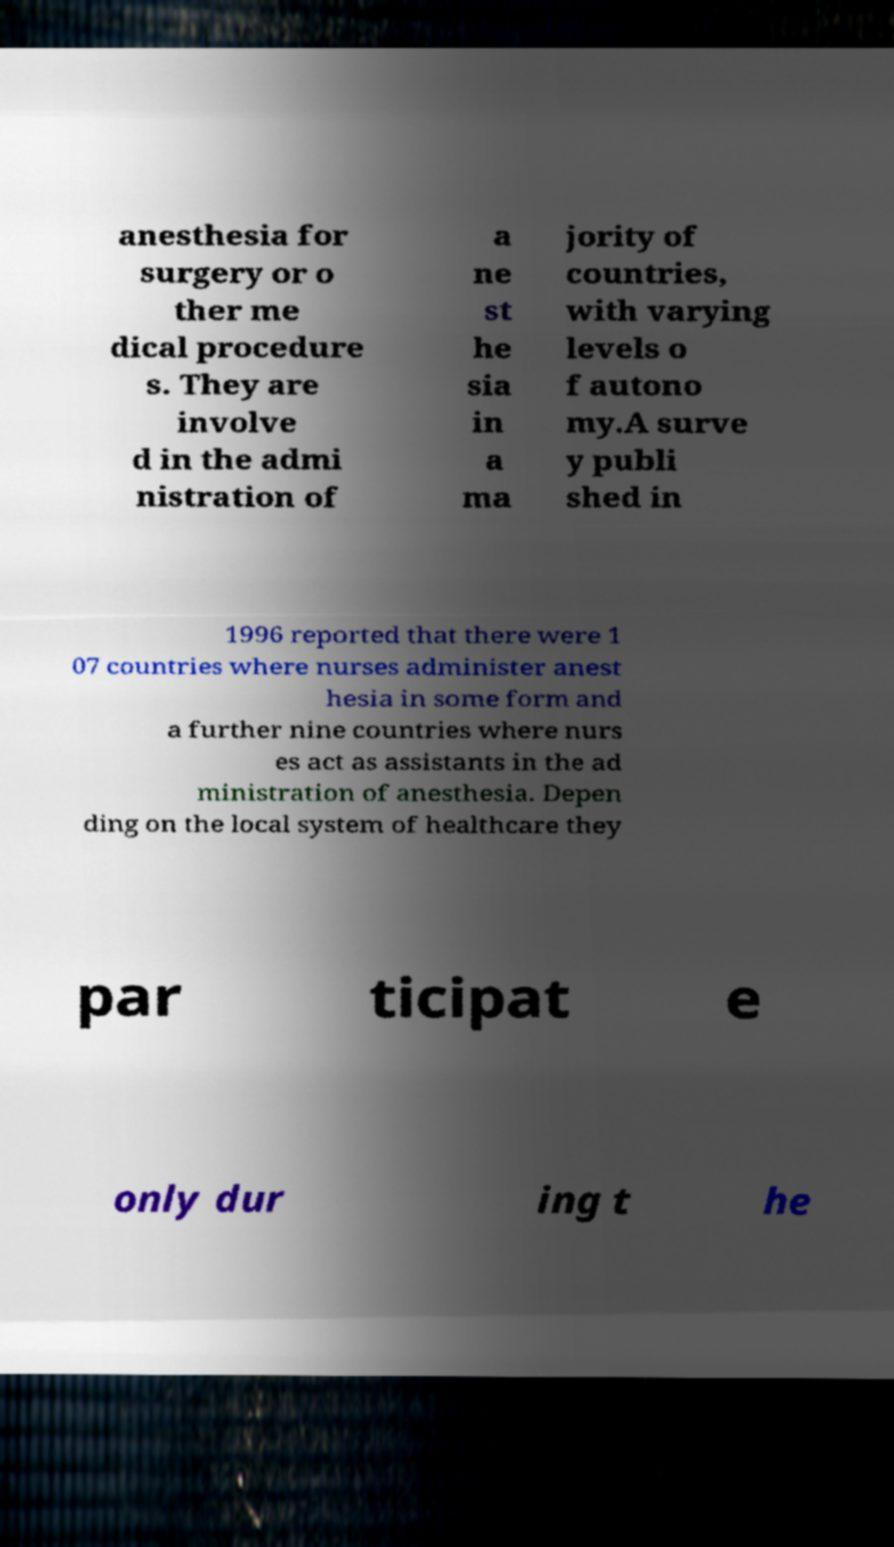Can you accurately transcribe the text from the provided image for me? anesthesia for surgery or o ther me dical procedure s. They are involve d in the admi nistration of a ne st he sia in a ma jority of countries, with varying levels o f autono my.A surve y publi shed in 1996 reported that there were 1 07 countries where nurses administer anest hesia in some form and a further nine countries where nurs es act as assistants in the ad ministration of anesthesia. Depen ding on the local system of healthcare they par ticipat e only dur ing t he 